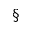Convert formula to latex. <formula><loc_0><loc_0><loc_500><loc_500>\S</formula> 